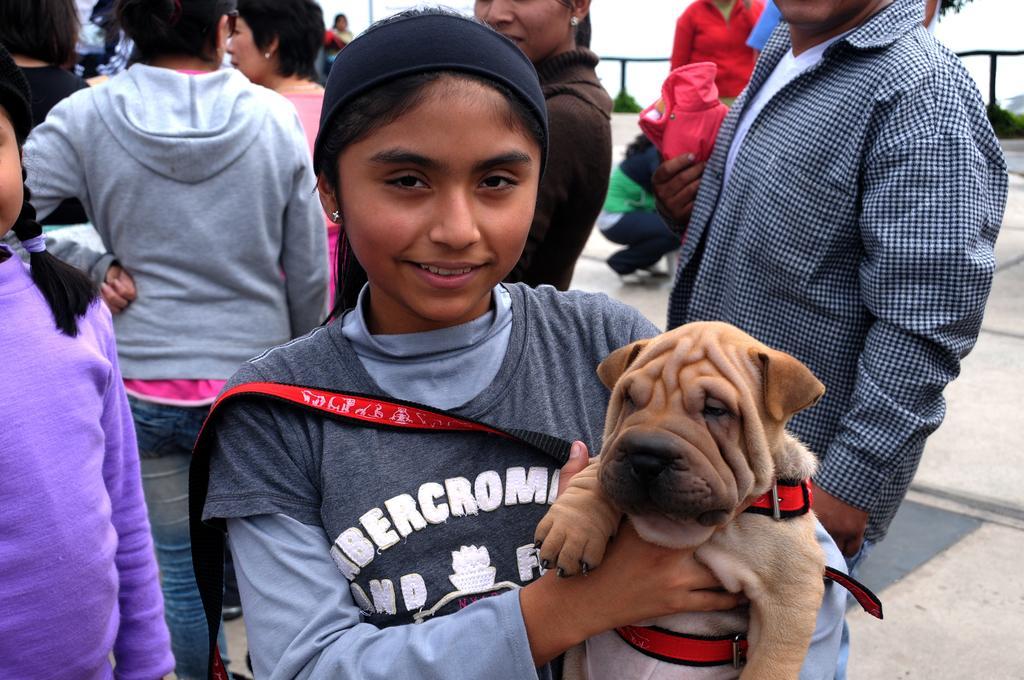How would you summarize this image in a sentence or two? This Image is clicked outside. There are so many people in this image all of them are standing and there is a girl in the middle, she is wearing black color shirt. She also has a dog in her hand. It is in brown color, it has a belt to her body. On the left side there is a girl who is wearing purple color t-shirt. 